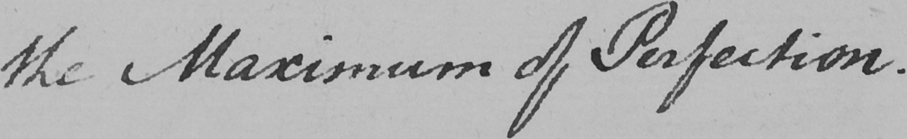What does this handwritten line say? the Maximum of Perfection . 